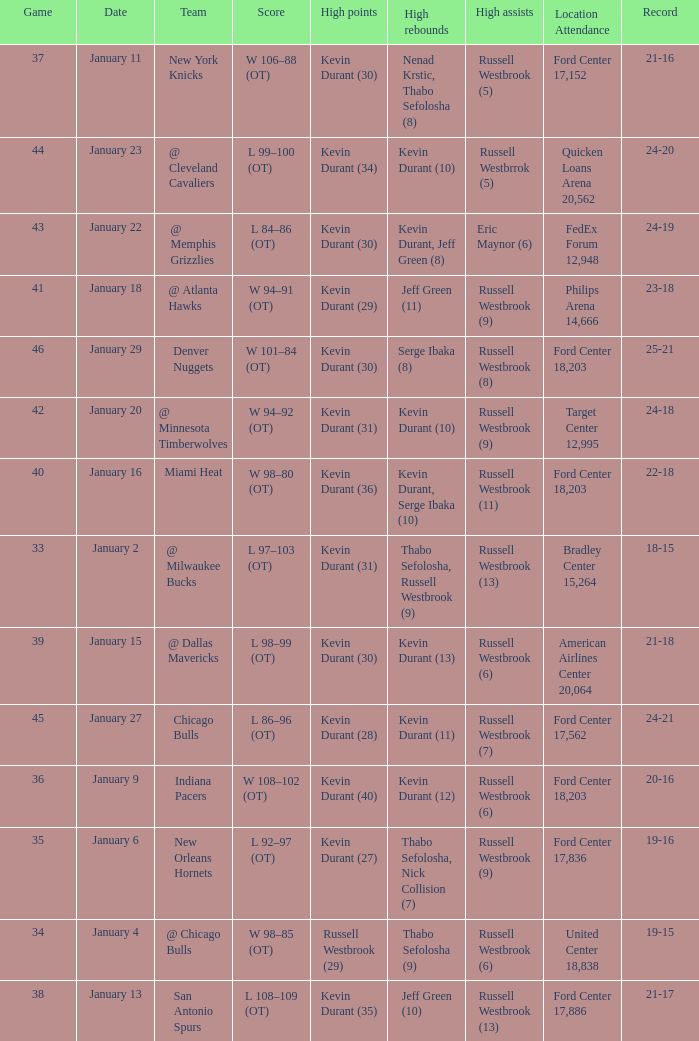Name the location attendance for january 18 Philips Arena 14,666. 